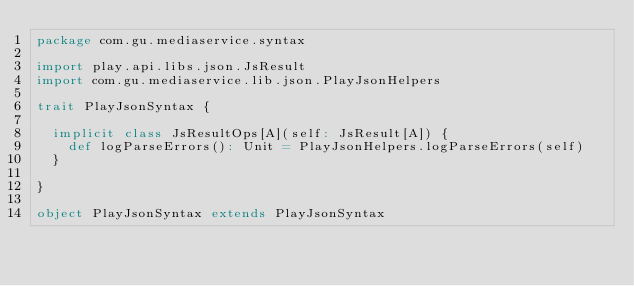Convert code to text. <code><loc_0><loc_0><loc_500><loc_500><_Scala_>package com.gu.mediaservice.syntax

import play.api.libs.json.JsResult
import com.gu.mediaservice.lib.json.PlayJsonHelpers

trait PlayJsonSyntax {

  implicit class JsResultOps[A](self: JsResult[A]) {
    def logParseErrors(): Unit = PlayJsonHelpers.logParseErrors(self)
  }

}

object PlayJsonSyntax extends PlayJsonSyntax
</code> 